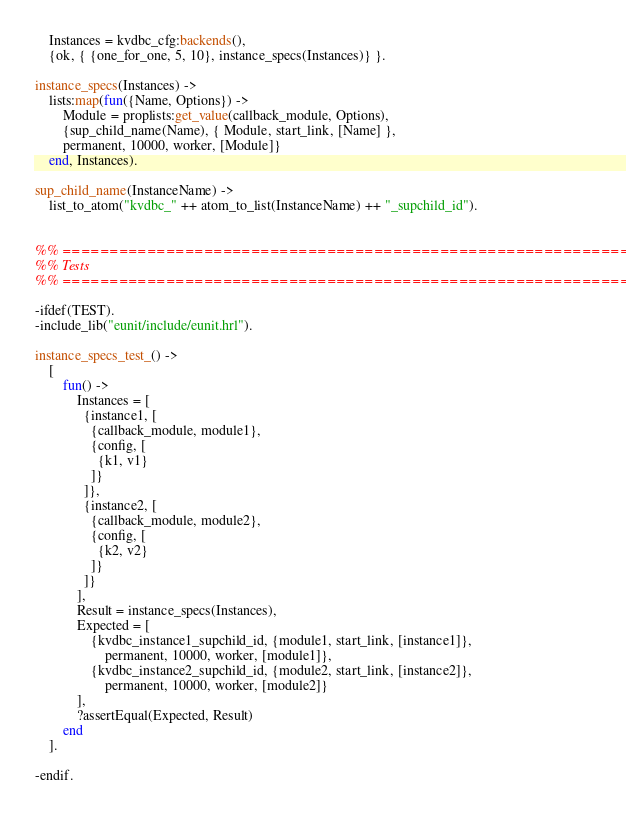Convert code to text. <code><loc_0><loc_0><loc_500><loc_500><_Erlang_>    Instances = kvdbc_cfg:backends(),
    {ok, { {one_for_one, 5, 10}, instance_specs(Instances)} }.

instance_specs(Instances) ->
    lists:map(fun({Name, Options}) ->
        Module = proplists:get_value(callback_module, Options),
        {sup_child_name(Name), { Module, start_link, [Name] },
        permanent, 10000, worker, [Module]}
    end, Instances).

sup_child_name(InstanceName) ->
    list_to_atom("kvdbc_" ++ atom_to_list(InstanceName) ++ "_supchild_id").


%% ===================================================================
%% Tests
%% ===================================================================

-ifdef(TEST).
-include_lib("eunit/include/eunit.hrl").

instance_specs_test_() ->
    [
        fun() ->
            Instances = [
              {instance1, [
                {callback_module, module1},
                {config, [
                  {k1, v1}
                ]}
              ]},
              {instance2, [
                {callback_module, module2},
                {config, [
                  {k2, v2}
                ]}
              ]}
            ],
            Result = instance_specs(Instances),
            Expected = [
                {kvdbc_instance1_supchild_id, {module1, start_link, [instance1]},
                    permanent, 10000, worker, [module1]},
                {kvdbc_instance2_supchild_id, {module2, start_link, [instance2]},
                    permanent, 10000, worker, [module2]}
            ],
            ?assertEqual(Expected, Result)
        end
    ].

-endif.
</code> 